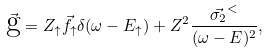Convert formula to latex. <formula><loc_0><loc_0><loc_500><loc_500>\vec { \text  g}=Z_{\uparrow} \vec{f_{\uparrow} } \delta ( \omega - E _ { \uparrow } ) + Z ^ { 2 } \frac { \vec { \sigma _ { 2 } } ^ { < } } { ( \omega - E ) ^ { 2 } } ,</formula> 